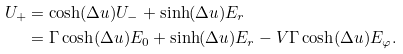<formula> <loc_0><loc_0><loc_500><loc_500>U _ { + } & = \cosh ( \Delta u ) U _ { - } + \sinh ( \Delta u ) E _ { r } \\ & = \Gamma \cosh ( \Delta u ) E _ { 0 } + \sinh ( \Delta u ) E _ { r } - V \Gamma \cosh ( \Delta u ) E _ { \varphi } .</formula> 